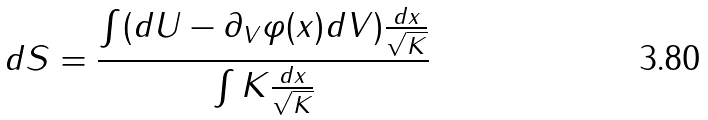<formula> <loc_0><loc_0><loc_500><loc_500>d S = \frac { \int ( d U - \partial _ { V } \varphi ( x ) d V ) \frac { d x } { \sqrt { K } } } { \int K \frac { d x } { \sqrt { K } } }</formula> 